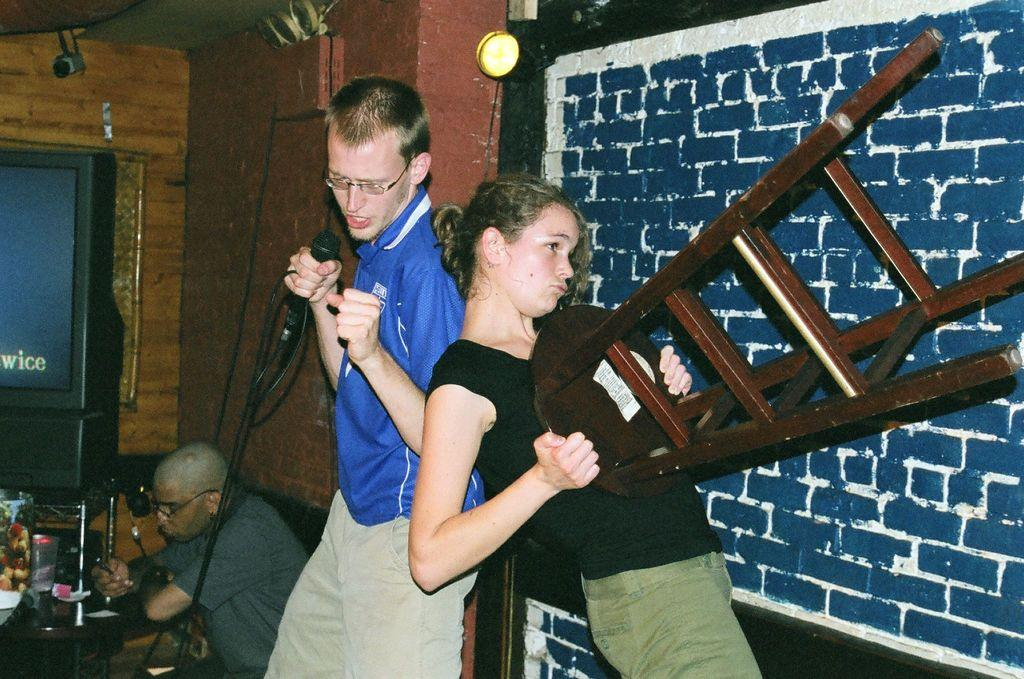What is the man in the image doing? The man is standing and singing into a microphone. Who else is present in the image? There is a girl and another man in the image. What is the girl doing? The girl is lifting a stool. What is the second man doing? The second man is sitting and doing something. What color is the sweater worn by the duck in the image? There is no duck present in the image, and therefore no sweater can be observed. What type of beast is interacting with the microphone in the image? There is no beast present in the image; only the man is interacting with the microphone. 